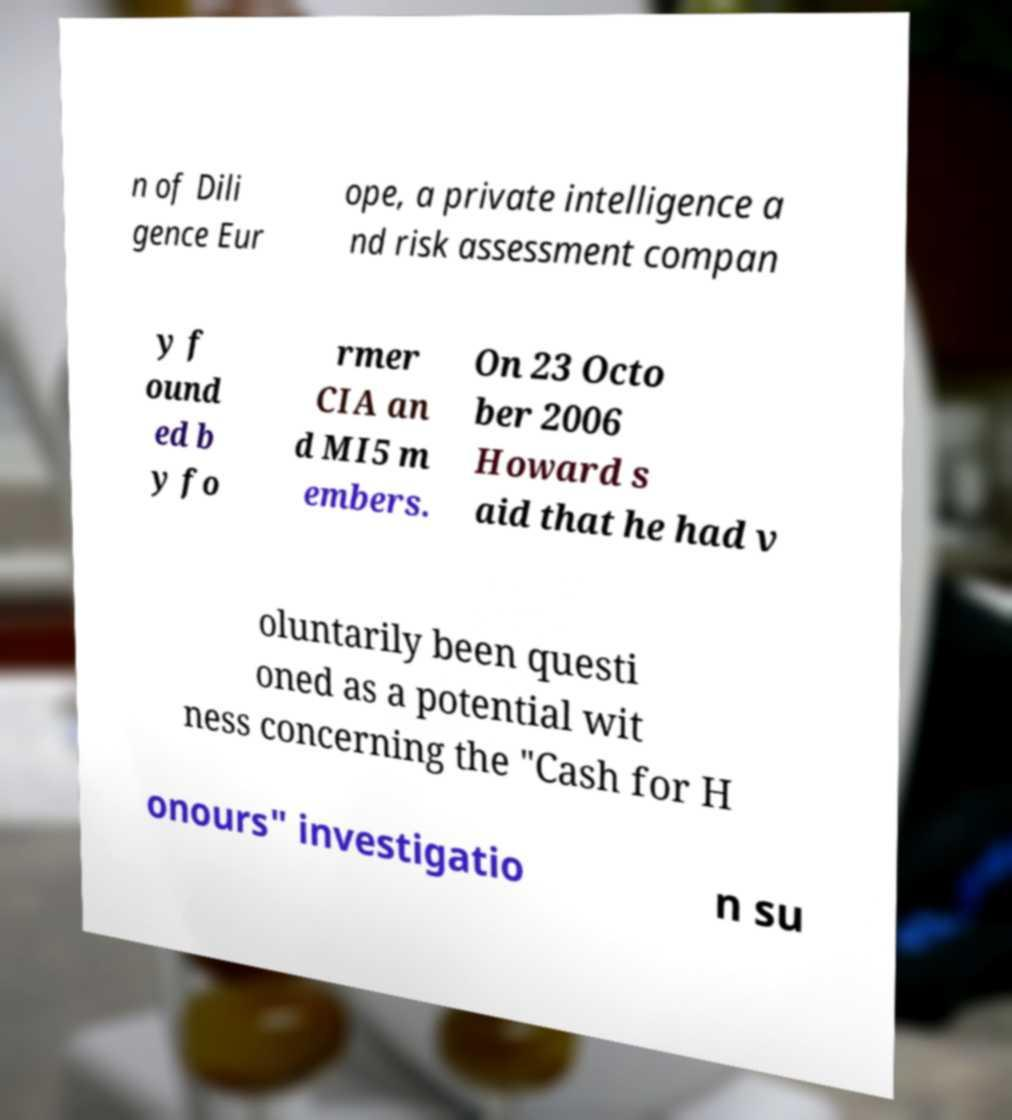Could you extract and type out the text from this image? n of Dili gence Eur ope, a private intelligence a nd risk assessment compan y f ound ed b y fo rmer CIA an d MI5 m embers. On 23 Octo ber 2006 Howard s aid that he had v oluntarily been questi oned as a potential wit ness concerning the "Cash for H onours" investigatio n su 